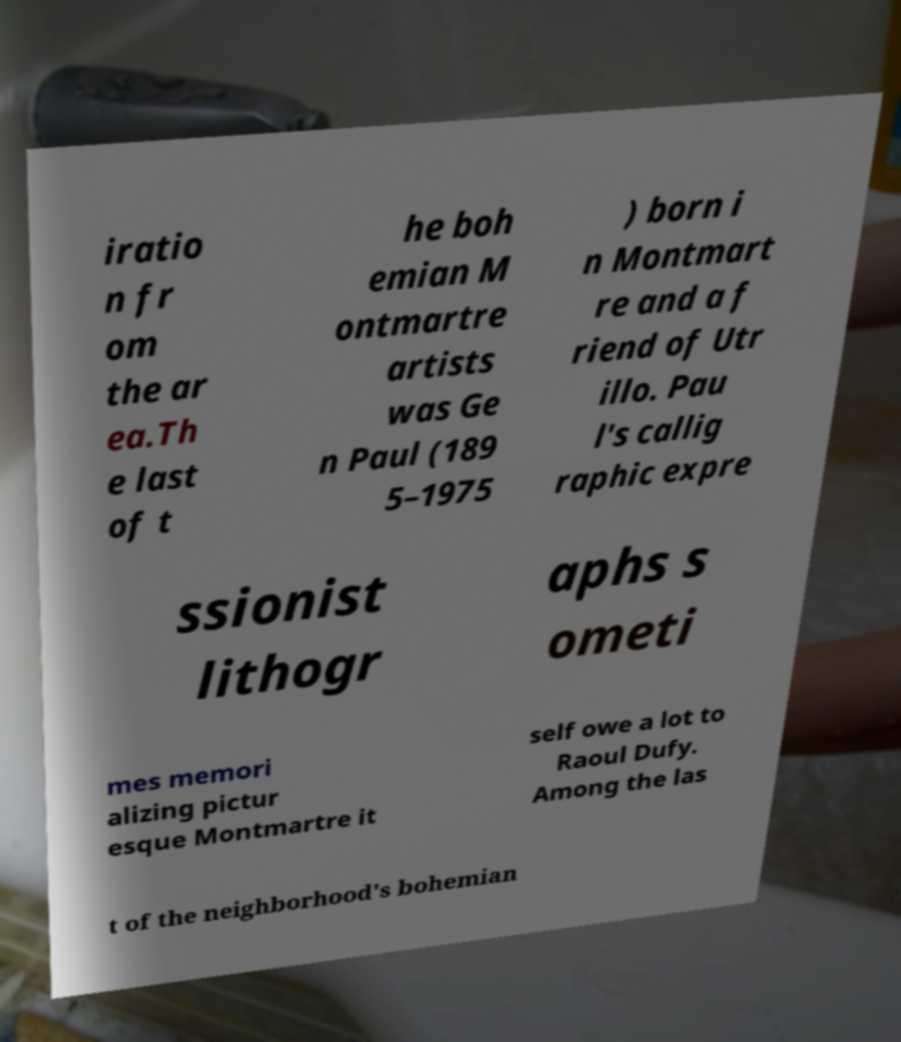Please read and relay the text visible in this image. What does it say? iratio n fr om the ar ea.Th e last of t he boh emian M ontmartre artists was Ge n Paul (189 5–1975 ) born i n Montmart re and a f riend of Utr illo. Pau l's callig raphic expre ssionist lithogr aphs s ometi mes memori alizing pictur esque Montmartre it self owe a lot to Raoul Dufy. Among the las t of the neighborhood's bohemian 